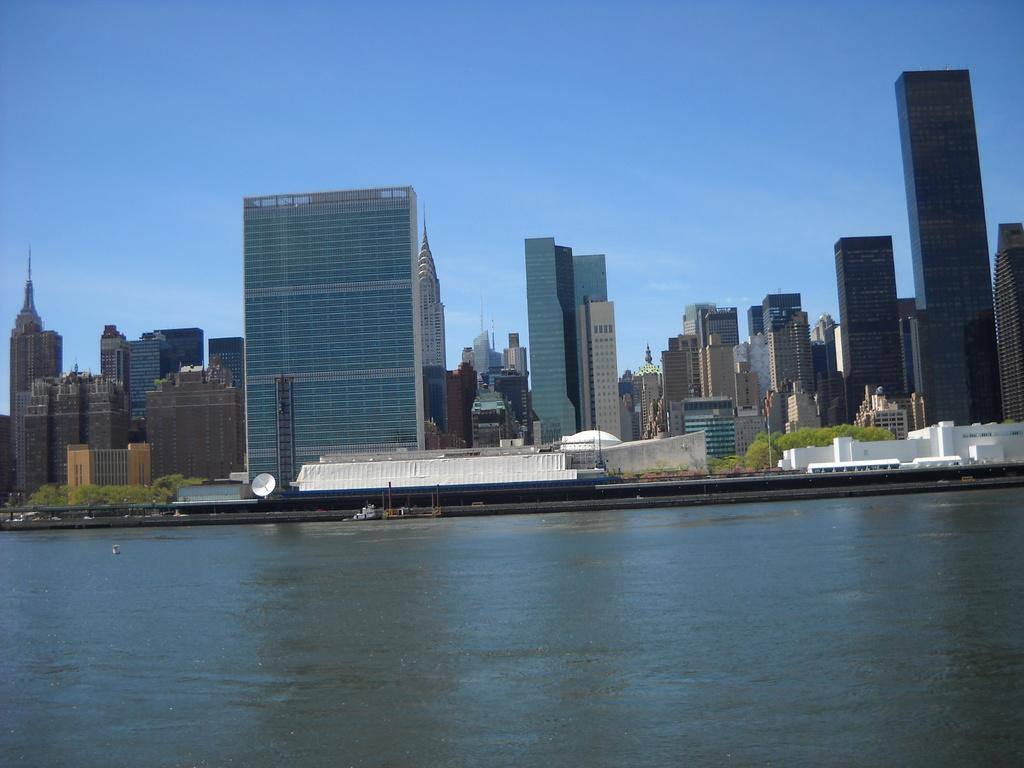What is the primary element visible in the image? There is water visible in the image. What can be seen in the background of the image? There are buildings in the background of the image, with white and brown colors. What type of vegetation is present in the image? There are plants in the image, with green colors. What is visible above the water and buildings in the image? The sky is visible in the image, with blue and white colors. What type of bike is depicted in the picture? There is no bike present in the image; it features water, buildings, plants, and the sky. 